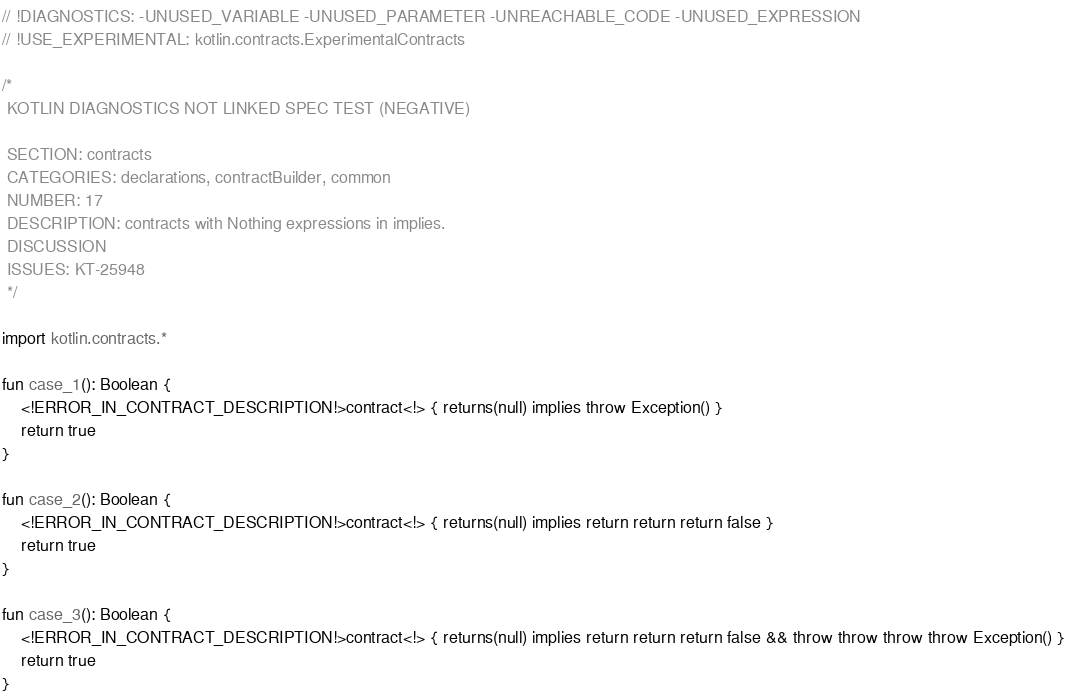Convert code to text. <code><loc_0><loc_0><loc_500><loc_500><_Kotlin_>// !DIAGNOSTICS: -UNUSED_VARIABLE -UNUSED_PARAMETER -UNREACHABLE_CODE -UNUSED_EXPRESSION
// !USE_EXPERIMENTAL: kotlin.contracts.ExperimentalContracts

/*
 KOTLIN DIAGNOSTICS NOT LINKED SPEC TEST (NEGATIVE)

 SECTION: contracts
 CATEGORIES: declarations, contractBuilder, common
 NUMBER: 17
 DESCRIPTION: contracts with Nothing expressions in implies.
 DISCUSSION
 ISSUES: KT-25948
 */

import kotlin.contracts.*

fun case_1(): Boolean {
    <!ERROR_IN_CONTRACT_DESCRIPTION!>contract<!> { returns(null) implies throw Exception() }
    return true
}

fun case_2(): Boolean {
    <!ERROR_IN_CONTRACT_DESCRIPTION!>contract<!> { returns(null) implies return return return false }
    return true
}

fun case_3(): Boolean {
    <!ERROR_IN_CONTRACT_DESCRIPTION!>contract<!> { returns(null) implies return return return false && throw throw throw throw Exception() }
    return true
}
</code> 